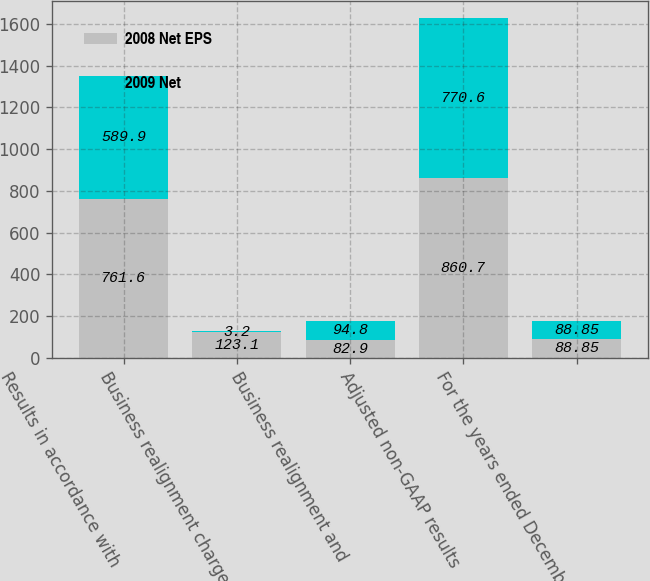Convert chart. <chart><loc_0><loc_0><loc_500><loc_500><stacked_bar_chart><ecel><fcel>Results in accordance with<fcel>Business realignment charges<fcel>Business realignment and<fcel>Adjusted non-GAAP results<fcel>For the years ended December<nl><fcel>2008 Net EPS<fcel>761.6<fcel>123.1<fcel>82.9<fcel>860.7<fcel>88.85<nl><fcel>2009 Net<fcel>589.9<fcel>3.2<fcel>94.8<fcel>770.6<fcel>88.85<nl></chart> 